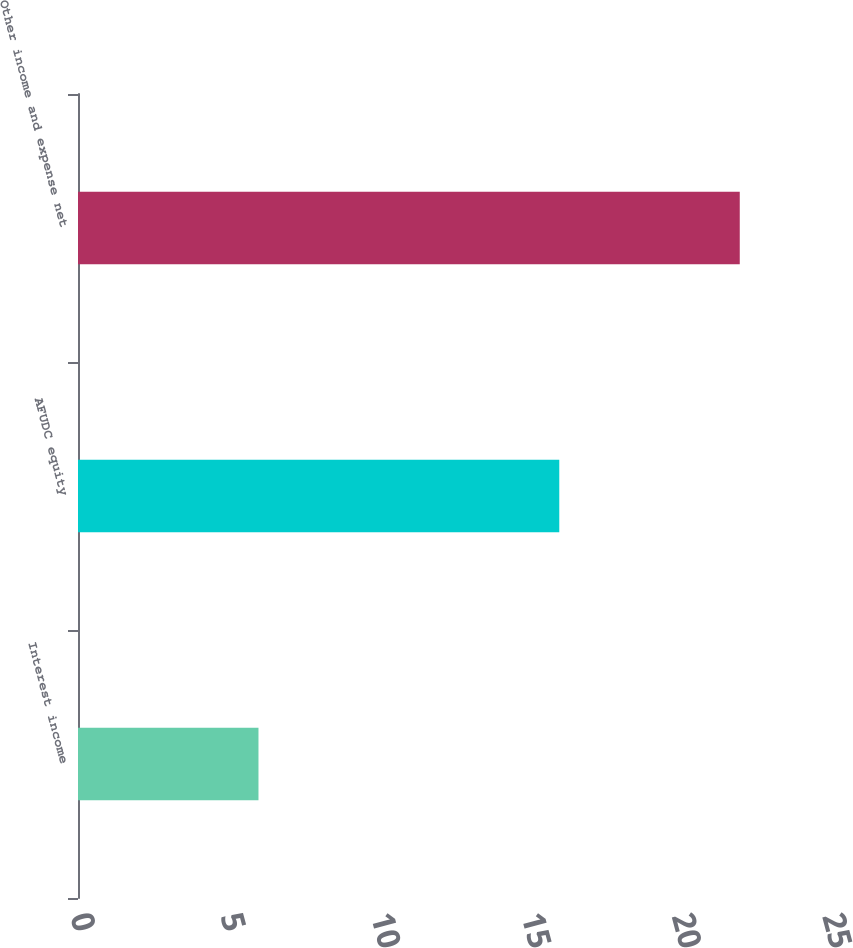<chart> <loc_0><loc_0><loc_500><loc_500><bar_chart><fcel>Interest income<fcel>AFUDC equity<fcel>Other income and expense net<nl><fcel>6<fcel>16<fcel>22<nl></chart> 